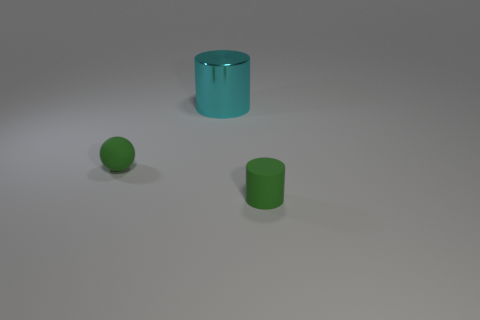The thing that is both in front of the large object and left of the small green rubber cylinder has what shape?
Offer a very short reply. Sphere. Does the big cyan cylinder have the same material as the cylinder that is in front of the metal object?
Ensure brevity in your answer.  No. There is a small green rubber sphere; are there any green matte things in front of it?
Ensure brevity in your answer.  Yes. How many objects are tiny matte spheres or small rubber objects that are behind the green rubber cylinder?
Ensure brevity in your answer.  1. There is a cylinder in front of the cyan metallic object that is to the left of the matte cylinder; what is its color?
Your response must be concise. Green. What number of other objects are there of the same material as the large object?
Provide a succinct answer. 0. What number of metallic things are big blue blocks or green objects?
Keep it short and to the point. 0. There is a tiny matte thing that is the same shape as the large cyan object; what is its color?
Offer a very short reply. Green. What number of objects are either tiny brown rubber spheres or small rubber things?
Give a very brief answer. 2. There is a object that is made of the same material as the tiny ball; what shape is it?
Make the answer very short. Cylinder. 